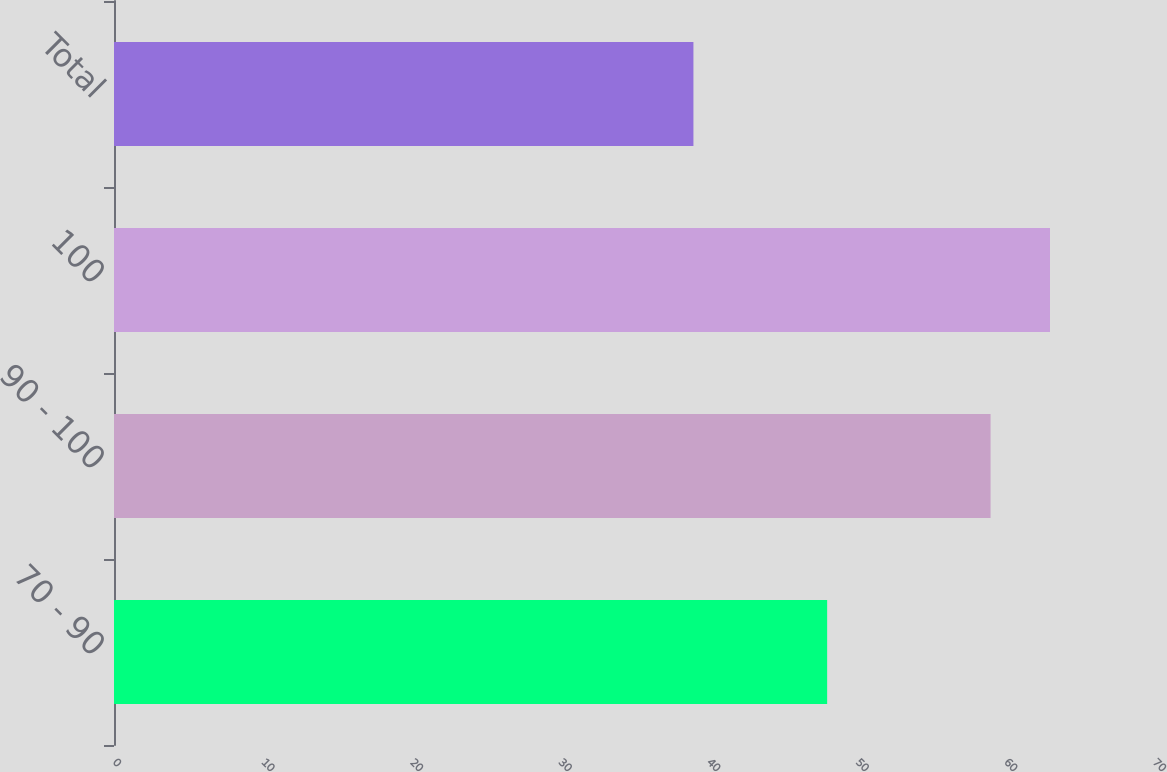Convert chart. <chart><loc_0><loc_0><loc_500><loc_500><bar_chart><fcel>70 - 90<fcel>90 - 100<fcel>100<fcel>Total<nl><fcel>48<fcel>59<fcel>63<fcel>39<nl></chart> 